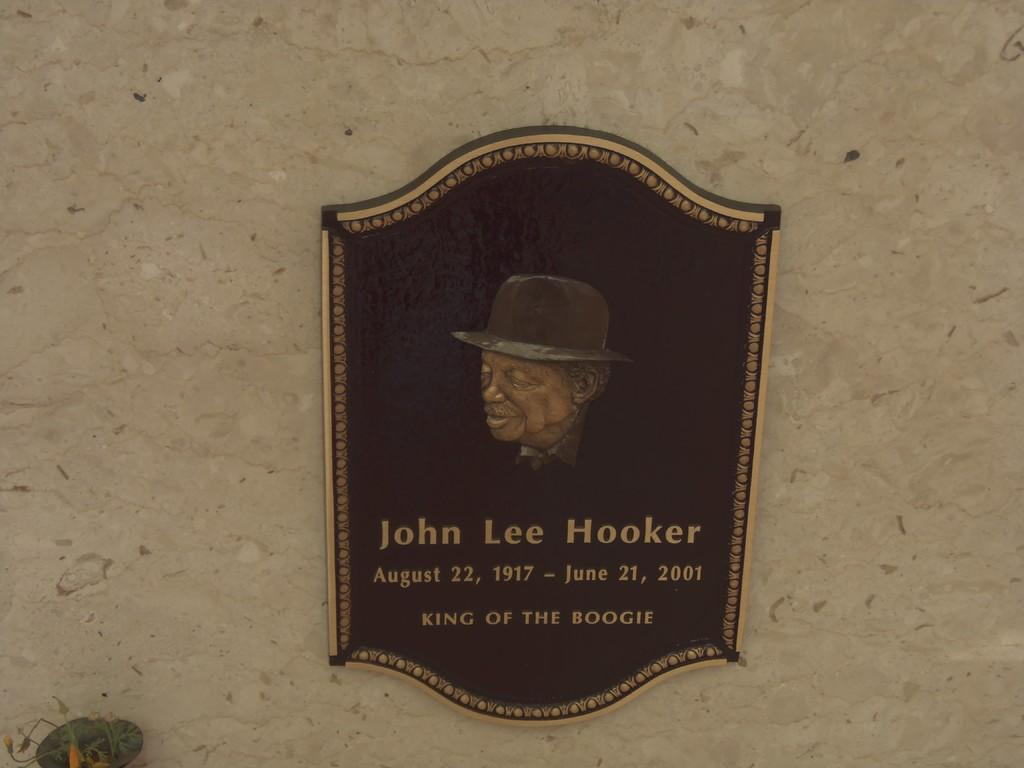What is the main object in the image? There is a wood board in the image. What is written or displayed on the wood board? There is a name on the wood board. Is there any image or illustration on the wood board? Yes, there is a picture of a person on the wood board. What type of cushion is placed on the wood board in the image? There is no cushion present on the wood board in the image. Is there a locket hanging from the picture of the person on the wood board? There is no locket visible in the image. 